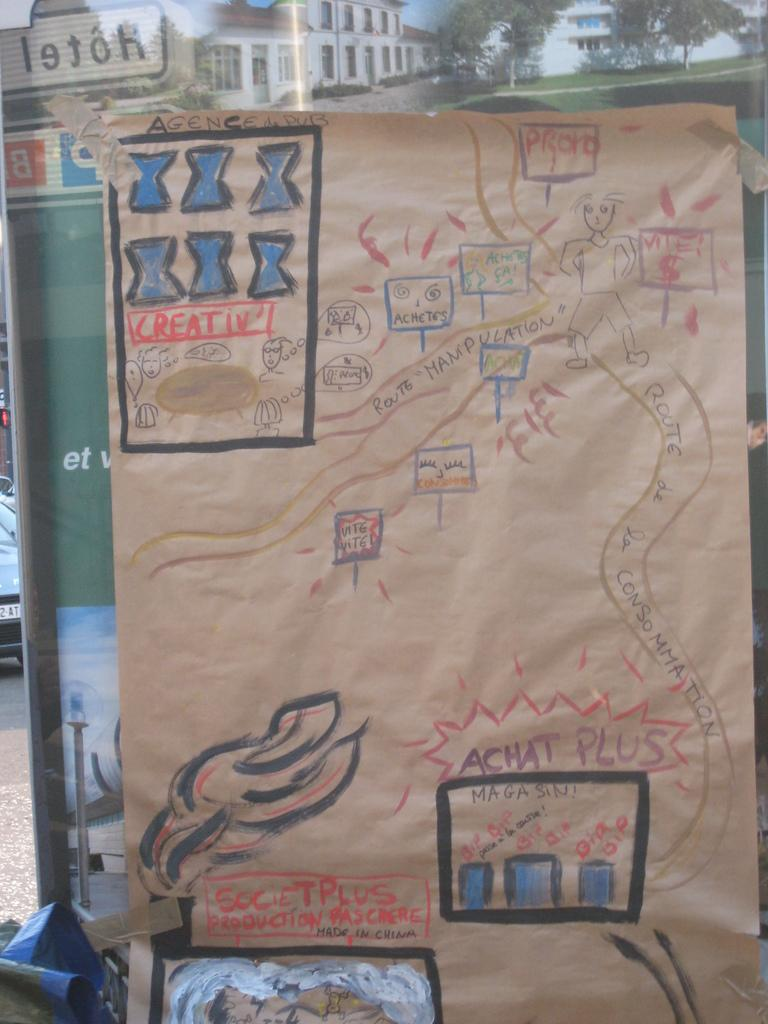<image>
Give a short and clear explanation of the subsequent image. Map drawn by a child for Agence de Pub. 